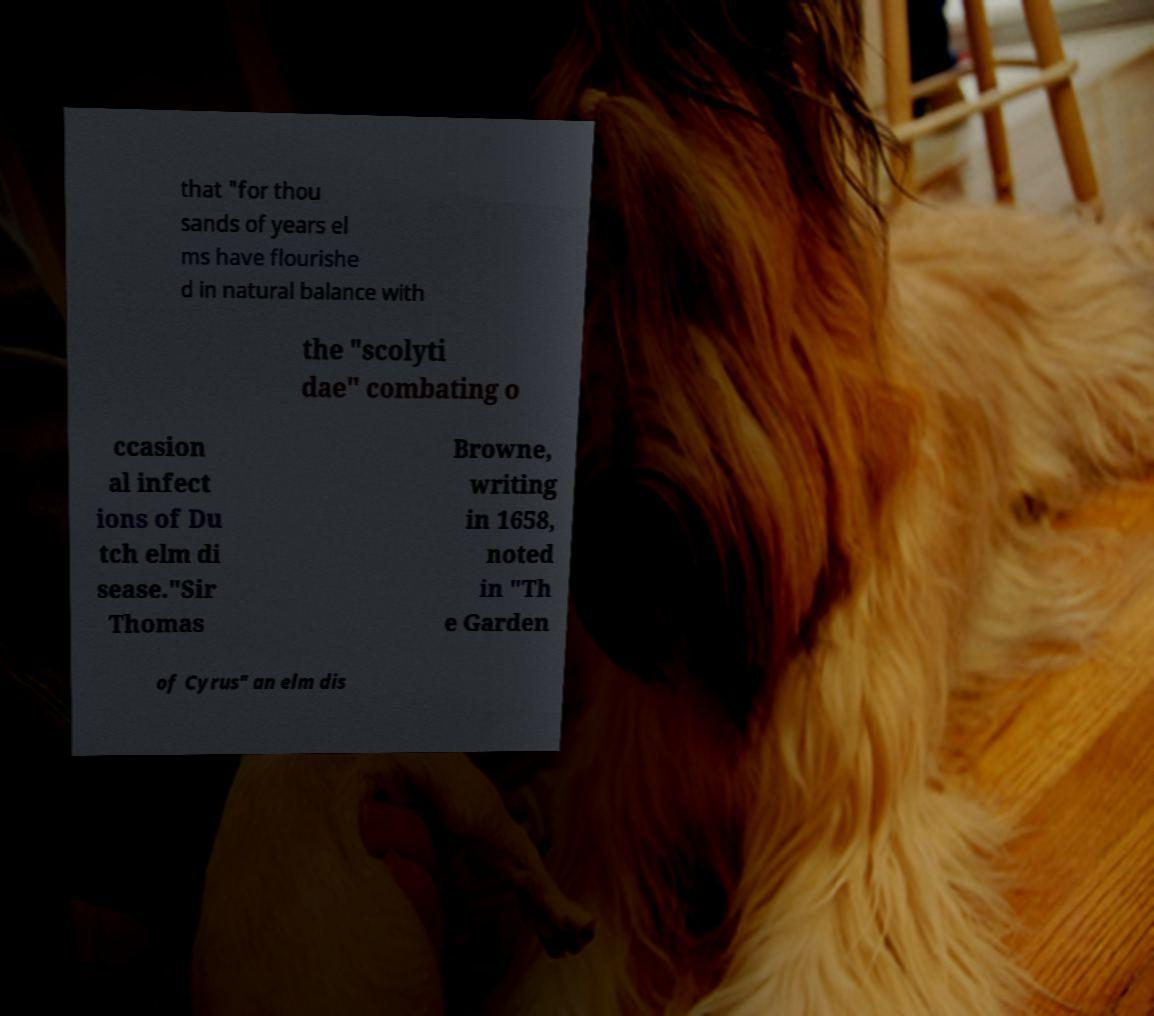Can you read and provide the text displayed in the image?This photo seems to have some interesting text. Can you extract and type it out for me? that "for thou sands of years el ms have flourishe d in natural balance with the "scolyti dae" combating o ccasion al infect ions of Du tch elm di sease."Sir Thomas Browne, writing in 1658, noted in "Th e Garden of Cyrus" an elm dis 